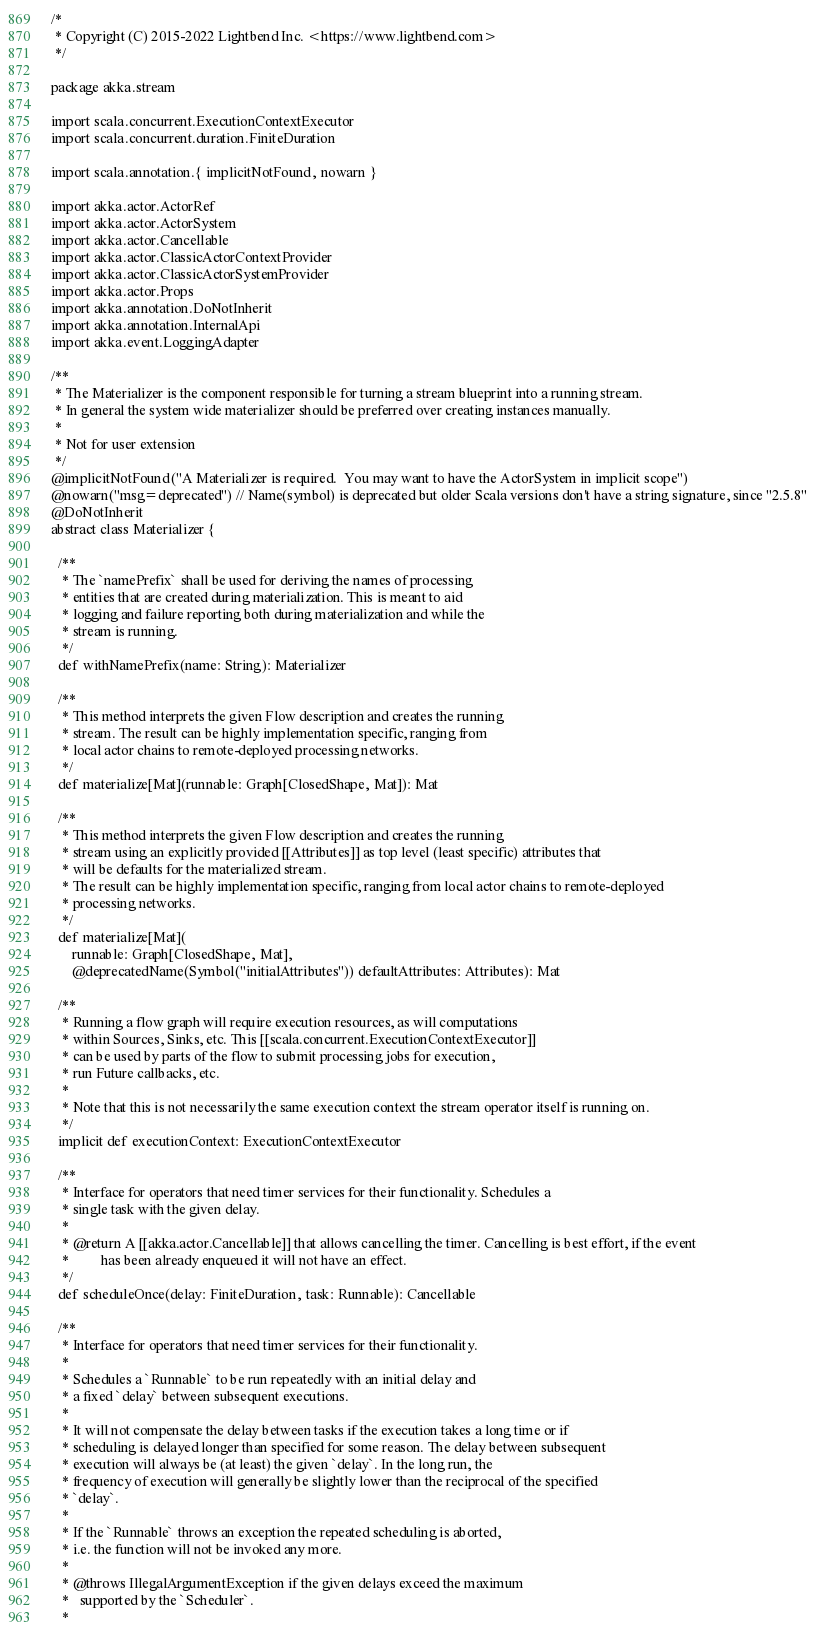<code> <loc_0><loc_0><loc_500><loc_500><_Scala_>/*
 * Copyright (C) 2015-2022 Lightbend Inc. <https://www.lightbend.com>
 */

package akka.stream

import scala.concurrent.ExecutionContextExecutor
import scala.concurrent.duration.FiniteDuration

import scala.annotation.{ implicitNotFound, nowarn }

import akka.actor.ActorRef
import akka.actor.ActorSystem
import akka.actor.Cancellable
import akka.actor.ClassicActorContextProvider
import akka.actor.ClassicActorSystemProvider
import akka.actor.Props
import akka.annotation.DoNotInherit
import akka.annotation.InternalApi
import akka.event.LoggingAdapter

/**
 * The Materializer is the component responsible for turning a stream blueprint into a running stream.
 * In general the system wide materializer should be preferred over creating instances manually.
 *
 * Not for user extension
 */
@implicitNotFound("A Materializer is required.  You may want to have the ActorSystem in implicit scope")
@nowarn("msg=deprecated") // Name(symbol) is deprecated but older Scala versions don't have a string signature, since "2.5.8"
@DoNotInherit
abstract class Materializer {

  /**
   * The `namePrefix` shall be used for deriving the names of processing
   * entities that are created during materialization. This is meant to aid
   * logging and failure reporting both during materialization and while the
   * stream is running.
   */
  def withNamePrefix(name: String): Materializer

  /**
   * This method interprets the given Flow description and creates the running
   * stream. The result can be highly implementation specific, ranging from
   * local actor chains to remote-deployed processing networks.
   */
  def materialize[Mat](runnable: Graph[ClosedShape, Mat]): Mat

  /**
   * This method interprets the given Flow description and creates the running
   * stream using an explicitly provided [[Attributes]] as top level (least specific) attributes that
   * will be defaults for the materialized stream.
   * The result can be highly implementation specific, ranging from local actor chains to remote-deployed
   * processing networks.
   */
  def materialize[Mat](
      runnable: Graph[ClosedShape, Mat],
      @deprecatedName(Symbol("initialAttributes")) defaultAttributes: Attributes): Mat

  /**
   * Running a flow graph will require execution resources, as will computations
   * within Sources, Sinks, etc. This [[scala.concurrent.ExecutionContextExecutor]]
   * can be used by parts of the flow to submit processing jobs for execution,
   * run Future callbacks, etc.
   *
   * Note that this is not necessarily the same execution context the stream operator itself is running on.
   */
  implicit def executionContext: ExecutionContextExecutor

  /**
   * Interface for operators that need timer services for their functionality. Schedules a
   * single task with the given delay.
   *
   * @return A [[akka.actor.Cancellable]] that allows cancelling the timer. Cancelling is best effort, if the event
   *         has been already enqueued it will not have an effect.
   */
  def scheduleOnce(delay: FiniteDuration, task: Runnable): Cancellable

  /**
   * Interface for operators that need timer services for their functionality.
   *
   * Schedules a `Runnable` to be run repeatedly with an initial delay and
   * a fixed `delay` between subsequent executions.
   *
   * It will not compensate the delay between tasks if the execution takes a long time or if
   * scheduling is delayed longer than specified for some reason. The delay between subsequent
   * execution will always be (at least) the given `delay`. In the long run, the
   * frequency of execution will generally be slightly lower than the reciprocal of the specified
   * `delay`.
   *
   * If the `Runnable` throws an exception the repeated scheduling is aborted,
   * i.e. the function will not be invoked any more.
   *
   * @throws IllegalArgumentException if the given delays exceed the maximum
   *   supported by the `Scheduler`.
   *</code> 